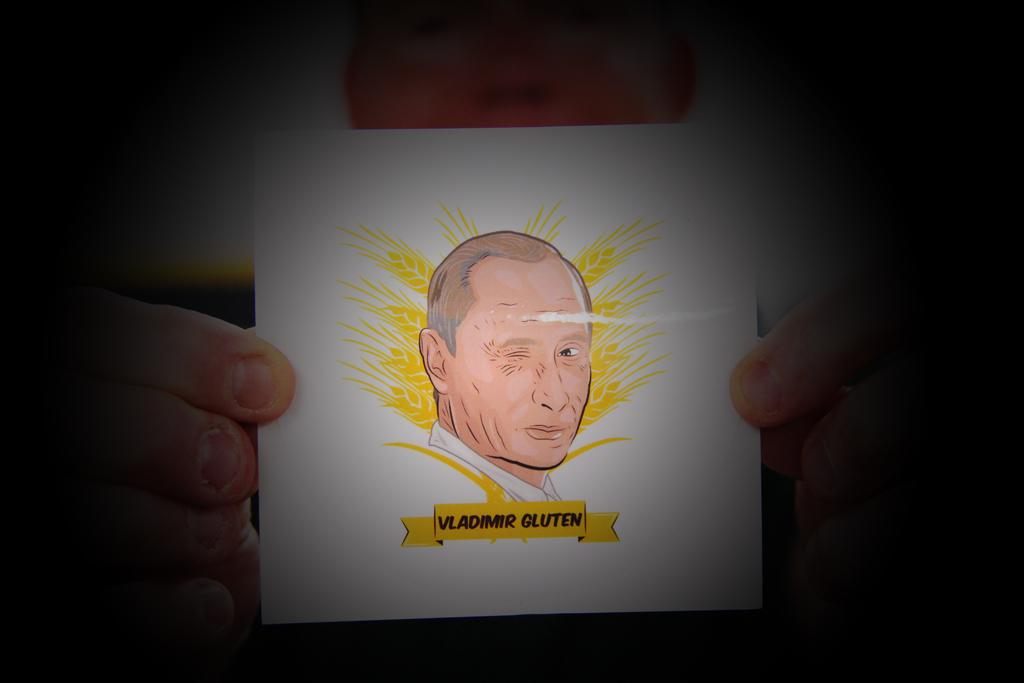What is present in the image? There is a person in the image. What is the person holding? The person is holding a sticker. What type of calculator is being used by the person in the image? There is no calculator present in the image; the person is holding a sticker. 